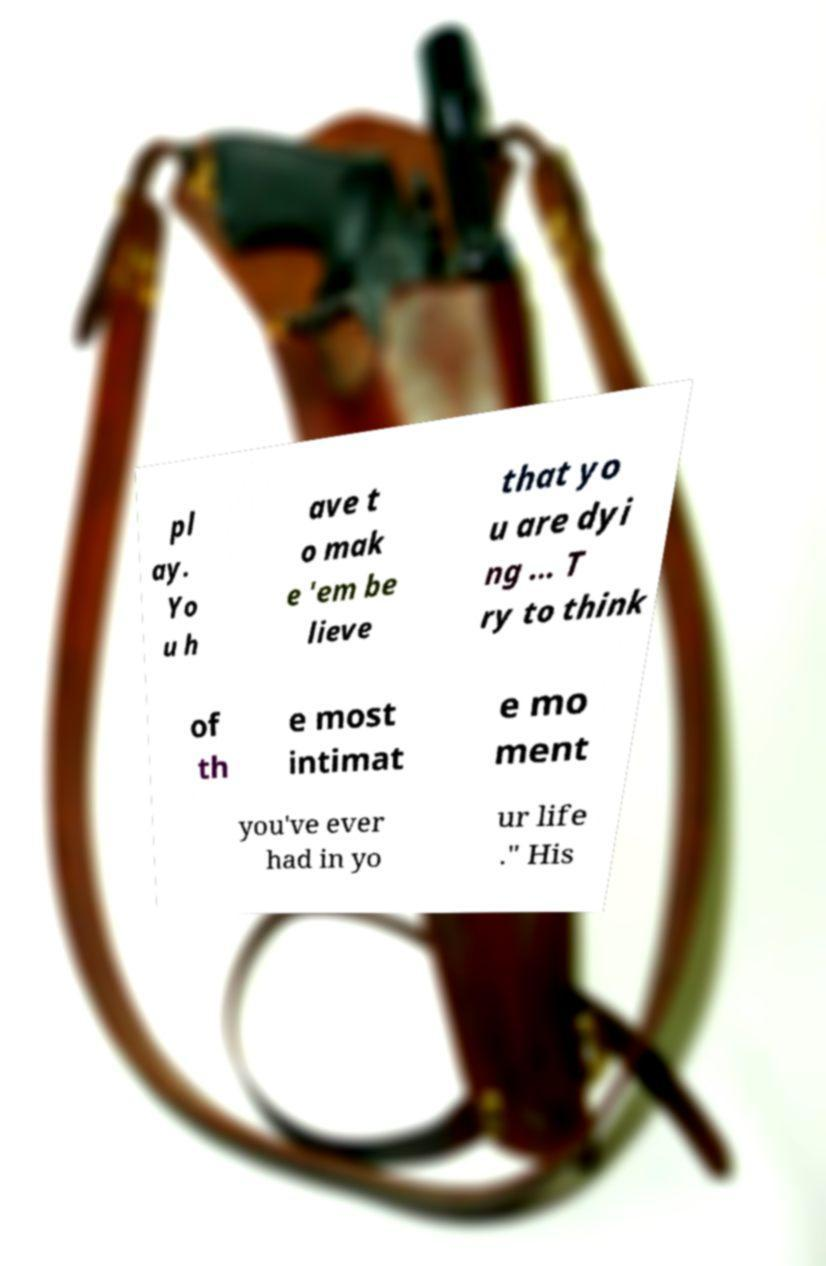Please identify and transcribe the text found in this image. pl ay. Yo u h ave t o mak e 'em be lieve that yo u are dyi ng ... T ry to think of th e most intimat e mo ment you've ever had in yo ur life ." His 